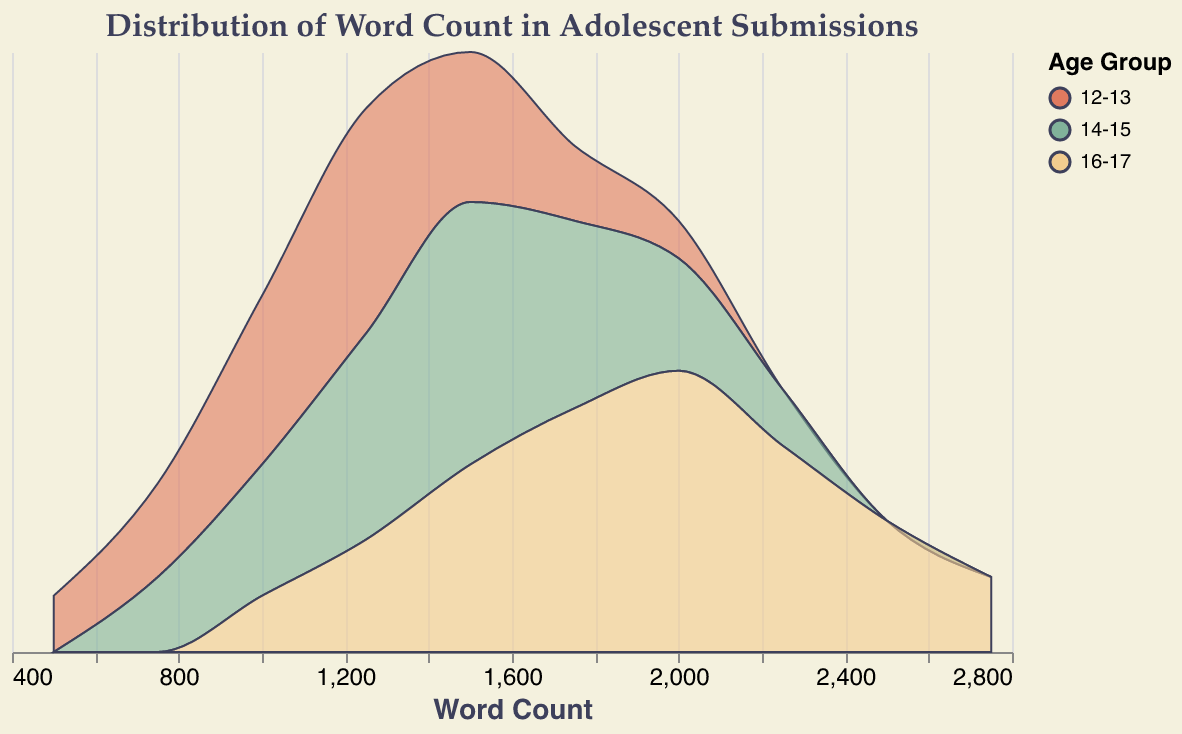What is the title of the figure? The title of the figure is usually found at the top and often provides a concise description of the data being visualized. Here, it reads, "Distribution of Word Count in Adolescent Submissions".
Answer: Distribution of Word Count in Adolescent Submissions Which age group has the highest density at a word count of 2000? Look at the ridgeline plot and find the word count of 2000. Then, check the "scaled_density" values at this word count for each age group. The age group with the highest value is 16-17, with a density of 75.
Answer: 16-17 Which age group shows the most submissions clustered around 1250 words? Identify the peaks in the ridgeline plots around the word count of 1250. The age group with the highest peak (density) indicates the most submissions clustered around this word count. For 1250, age group 12-13 has the highest peak with a density of 0.6.
Answer: 12-13 What is the color representation of the age group 14-15? The legend in the ridgeline plot indicates the color assigned to each age group. For age group 14-15, the corresponding color is a shade of green.
Answer: Green For the age group 12-13, what is the word count with the lowest density value, and what is that value? By examining the ridgeline plot for the 12-13 age group, we identify that the word count 2000 has the lowest density value, which is 0.0001.
Answer: Word count 2000, density 0.0001 Which age group has the widest range of word counts with significant submission densities? Look at the word count axis and observe the span of word counts with noticeable densities for each age group. The age group 16-17 has significant densities ranging from 1000 to 2750, the widest range among the groups.
Answer: 16-17 How does the peak density of submissions for the 16-17 age group at 2000 words compare to the peak density for the 14-15 age group at 1500 words? Locate the peak densities at mentioned word counts for the age groups. For 16-17 at 2000 words, it is 0.00075. For 14-15 at 1500 words, it is 0.00070. The peak density for 16-17 is higher.
Answer: Higher for 16-17 at 2000 Between the age groups 14-15 and 16-17, which one shows more variation in the distribution of word counts? Compare the shapes and spread of the density plots for both age groups. The age group 16-17 shows more variation (a wider spread of densities) from 1000 to 2750 word counts than 14-15, which is closely packed around 1250 to 2000 word counts.
Answer: 16-17 What can you infer about the trend in word count distribution as the age group progresses from 12-13 to 16-17? Observe the ridgeline plots for each age group. Younger groups (12-13) tend to cluster around lower word counts (750-1500), while older groups (16-17) show a broader distribution, including higher word counts up to 2750. This suggests older adolescents tend to write longer submissions.
Answer: Longer submissions with older age groups 